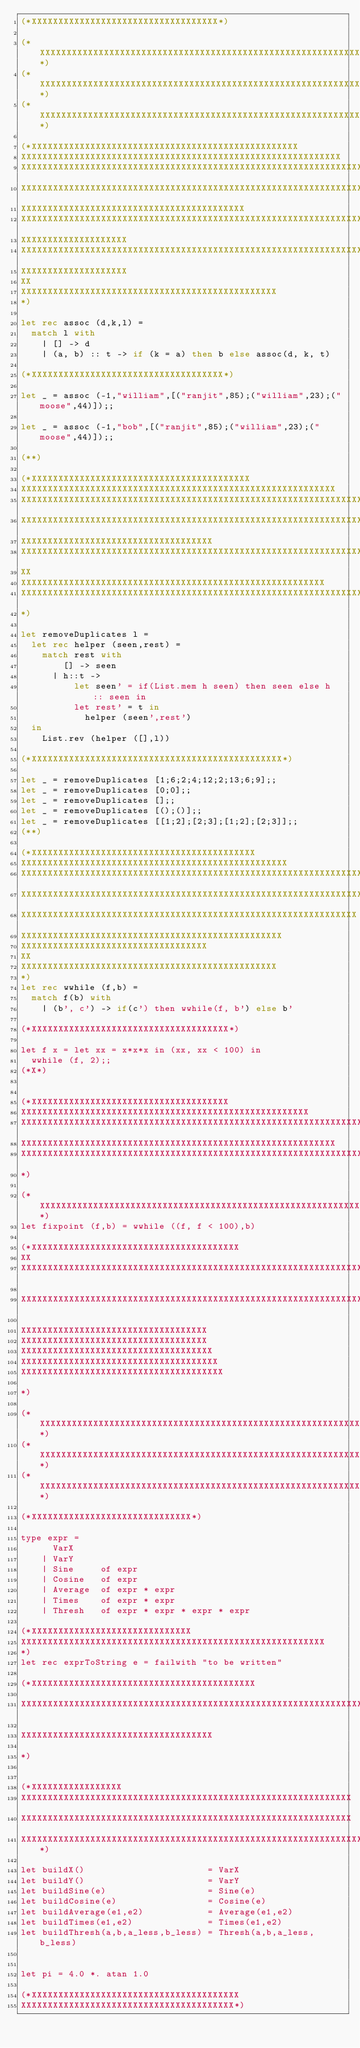Convert code to text. <code><loc_0><loc_0><loc_500><loc_500><_OCaml_>(*XXXXXXXXXXXXXXXXXXXXXXXXXXXXXXXXXXX*)

(*XXXXXXXXXXXXXXXXXXXXXXXXXXXXXXXXXXXXXXXXXXXXXXXXXXXXXXXXXXXXXXXXXXXXXXXXXXXXXXXXXXXXXX*)
(*XXXXXXXXXXXXXXXXXXXXXXXXXXXXXXXXXXXXXXXXXXXXXXXXXXXXXXXXXXXXXXXXXXXXXXXXXXXXXXXXXXXXXX*)
(*XXXXXXXXXXXXXXXXXXXXXXXXXXXXXXXXXXXXXXXXXXXXXXXXXXXXXXXXXXXXXXXXXXXXXXXXXXXXXXXXXXXXXX*)

(*XXXXXXXXXXXXXXXXXXXXXXXXXXXXXXXXXXXXXXXXXXXXXXXXXX
XXXXXXXXXXXXXXXXXXXXXXXXXXXXXXXXXXXXXXXXXXXXXXXXXXXXXXXXXXXX
XXXXXXXXXXXXXXXXXXXXXXXXXXXXXXXXXXXXXXXXXXXXXXXXXXXXXXXXXXXXXXXXXXXXXXXXXXXXXXXXXXX
XXXXXXXXXXXXXXXXXXXXXXXXXXXXXXXXXXXXXXXXXXXXXXXXXXXXXXXXXXXXXXXXXXXXXXXXXXXXXXXXXXXXX
XXXXXXXXXXXXXXXXXXXXXXXXXXXXXXXXXXXXXXXXXX
XXXXXXXXXXXXXXXXXXXXXXXXXXXXXXXXXXXXXXXXXXXXXXXXXXXXXXXXXXXXXXXXXXXXXXXXXX
XXXXXXXXXXXXXXXXXXXX
XXXXXXXXXXXXXXXXXXXXXXXXXXXXXXXXXXXXXXXXXXXXXXXXXXXXXXXXXXXXXXXXXXXXXX
XXXXXXXXXXXXXXXXXXXX
XX
XXXXXXXXXXXXXXXXXXXXXXXXXXXXXXXXXXXXXXXXXXXXXXXX
*)

let rec assoc (d,k,l) = 
  match l with
    | [] -> d
    | (a, b) :: t -> if (k = a) then b else assoc(d, k, t) 

(*XXXXXXXXXXXXXXXXXXXXXXXXXXXXXXXXXXXX*)

let _ = assoc (-1,"william",[("ranjit",85);("william",23);("moose",44)]);;    

let _ = assoc (-1,"bob",[("ranjit",85);("william",23);("moose",44)]);;

(**)

(*XXXXXXXXXXXXXXXXXXXXXXXXXXXXXXXXXXXXXXXXX
XXXXXXXXXXXXXXXXXXXXXXXXXXXXXXXXXXXXXXXXXXXXXXXXXXXXXXXXXXX
XXXXXXXXXXXXXXXXXXXXXXXXXXXXXXXXXXXXXXXXXXXXXXXXXXXXXXXXXXXXXXXXXXXXXXXXXXXXX
XXXXXXXXXXXXXXXXXXXXXXXXXXXXXXXXXXXXXXXXXXXXXXXXXXXXXXXXXXXXXXXXXXXX
XXXXXXXXXXXXXXXXXXXXXXXXXXXXXXXXXXXX
XXXXXXXXXXXXXXXXXXXXXXXXXXXXXXXXXXXXXXXXXXXXXXXXXXXXXXXXXXXXXXXXXXXXX
XX
XXXXXXXXXXXXXXXXXXXXXXXXXXXXXXXXXXXXXXXXXXXXXXXXXXXXXXXXX
XXXXXXXXXXXXXXXXXXXXXXXXXXXXXXXXXXXXXXXXXXXXXXXXXXXXXXXXXXXXXXXXXXXXXXXXXXXXXXXX
*)

let removeDuplicates l = 
  let rec helper (seen,rest) = 
    match rest with 
        [] -> seen
      | h::t -> 
          let seen' = if(List.mem h seen) then seen else h :: seen in
          let rest' = t in
            helper (seen',rest') 
  in 
    List.rev (helper ([],l))

(*XXXXXXXXXXXXXXXXXXXXXXXXXXXXXXXXXXXXXXXXXXXXXXX*)

let _ = removeDuplicates [1;6;2;4;12;2;13;6;9];;
let _ = removeDuplicates [0;0];;
let _ = removeDuplicates [];;
let _ = removeDuplicates [();()];;
let _ = removeDuplicates [[1;2];[2;3];[1;2];[2;3]];;
(**)

(*XXXXXXXXXXXXXXXXXXXXXXXXXXXXXXXXXXXXXXXXXX
XXXXXXXXXXXXXXXXXXXXXXXXXXXXXXXXXXXXXXXXXXXXXXXXXX
XXXXXXXXXXXXXXXXXXXXXXXXXXXXXXXXXXXXXXXXXXXXXXXXXXXXXXXXXXXXXXXXXXXXXXXXXXXXX
XXXXXXXXXXXXXXXXXXXXXXXXXXXXXXXXXXXXXXXXXXXXXXXXXXXXXXXXXXXXXXXXXXXXXXXXXXXXXXXXXXXX
XXXXXXXXXXXXXXXXXXXXXXXXXXXXXXXXXXXXXXXXXXXXXXXXXXXXXXXXXXXXXXX
XXXXXXXXXXXXXXXXXXXXXXXXXXXXXXXXXXXXXXXXXXXXXXXXX
XXXXXXXXXXXXXXXXXXXXXXXXXXXXXXXXXXX
XX
XXXXXXXXXXXXXXXXXXXXXXXXXXXXXXXXXXXXXXXXXXXXXXXX
*)
let rec wwhile (f,b) = 
  match f(b) with
    | (b', c') -> if(c') then wwhile(f, b') else b' 

(*XXXXXXXXXXXXXXXXXXXXXXXXXXXXXXXXXXXXX*)

let f x = let xx = x*x*x in (xx, xx < 100) in
  wwhile (f, 2);;
(*X*)


(*XXXXXXXXXXXXXXXXXXXXXXXXXXXXXXXXXXXXX
XXXXXXXXXXXXXXXXXXXXXXXXXXXXXXXXXXXXXXXXXXXXXXXXXXXXXX
XXXXXXXXXXXXXXXXXXXXXXXXXXXXXXXXXXXXXXXXXXXXXXXXXXXXXXXXXXXXXXXXXXXXXXXXXXXXXXXXX
XXXXXXXXXXXXXXXXXXXXXXXXXXXXXXXXXXXXXXXXXXXXXXXXXXXXXXXXXXX
XXXXXXXXXXXXXXXXXXXXXXXXXXXXXXXXXXXXXXXXXXXXXXXXXXXXXXXXXXXXXXXXXXXXXXXXXXXXXXXXXXXXXXXXXXXXXXXXXXXX
*)

(*XXXXXXXXXXXXXXXXXXXXXXXXXXXXXXXXXXXXXXXXXXXXXXXXXXXXXXXXXXXXXX*)
let fixpoint (f,b) = wwhile ((f, f < 100),b)

(*XXXXXXXXXXXXXXXXXXXXXXXXXXXXXXXXXXXXXXX
XX
XXXXXXXXXXXXXXXXXXXXXXXXXXXXXXXXXXXXXXXXXXXXXXXXXXXXXXXXXXXXXXXXXXXXXXXXXX

XXXXXXXXXXXXXXXXXXXXXXXXXXXXXXXXXXXXXXXXXXXXXXXXXXXXXXXXXXXXXXXXXXXXXXXXXXXXXXXXXXX

XXXXXXXXXXXXXXXXXXXXXXXXXXXXXXXXXXX
XXXXXXXXXXXXXXXXXXXXXXXXXXXXXXXXXXX
XXXXXXXXXXXXXXXXXXXXXXXXXXXXXXXXXXXX
XXXXXXXXXXXXXXXXXXXXXXXXXXXXXXXXXXXXX
XXXXXXXXXXXXXXXXXXXXXXXXXXXXXXXXXXXXXX

*)

(*XXXXXXXXXXXXXXXXXXXXXXXXXXXXXXXXXXXXXXXXXXXXXXXXXXXXXXXXXXXXXXXXXXXXXXXXXXXXXXXXXXXXXX*)
(*XXXXXXXXXXXXXXXXXXXXXXXXXXXXXXXXXXXXXXXXXXXXXXXXXXXXXXXXXXXXXXXXXXXXXXXXXXXXXXXXXXXXXX*)
(*XXXXXXXXXXXXXXXXXXXXXXXXXXXXXXXXXXXXXXXXXXXXXXXXXXXXXXXXXXXXXXXXXXXXXXXXXXXXXXXXXXXXXX*)

(*XXXXXXXXXXXXXXXXXXXXXXXXXXXXXX*) 

type expr = 
      VarX
    | VarY
    | Sine     of expr
    | Cosine   of expr
    | Average  of expr * expr
    | Times    of expr * expr
    | Thresh   of expr * expr * expr * expr	

(*XXXXXXXXXXXXXXXXXXXXXXXXXXXXXX
XXXXXXXXXXXXXXXXXXXXXXXXXXXXXXXXXXXXXXXXXXXXXXXXXXXXXXXXX
*)
let rec exprToString e = failwith "to be written"

(*XXXXXXXXXXXXXXXXXXXXXXXXXXXXXXXXXXXXXXXXXX

XXXXXXXXXXXXXXXXXXXXXXXXXXXXXXXXXXXXXXXXXXXXXXXXXXXXXXXXXXXXXXXXXXXXXXXXXXXXXXXXXXXXXXXXXXXX

XXXXXXXXXXXXXXXXXXXXXXXXXXXXXXXXXXXX

*)


(*XXXXXXXXXXXXXXXXX
XXXXXXXXXXXXXXXXXXXXXXXXXXXXXXXXXXXXXXXXXXXXXXXXXXXXXXXXXXXXXX
XXXXXXXXXXXXXXXXXXXXXXXXXXXXXXXXXXXXXXXXXXXXXXXXXXXXXXXXXXXXXX
XXXXXXXXXXXXXXXXXXXXXXXXXXXXXXXXXXXXXXXXXXXXXXXXXXXXXXXXXXXXXXXXXXX*)

let buildX()                       = VarX
let buildY()                       = VarY
let buildSine(e)                   = Sine(e)
let buildCosine(e)                 = Cosine(e)
let buildAverage(e1,e2)            = Average(e1,e2)
let buildTimes(e1,e2)              = Times(e1,e2)
let buildThresh(a,b,a_less,b_less) = Thresh(a,b,a_less,b_less)


let pi = 4.0 *. atan 1.0

(*XXXXXXXXXXXXXXXXXXXXXXXXXXXXXXXXXXXXXXX
XXXXXXXXXXXXXXXXXXXXXXXXXXXXXXXXXXXXXXXX*)
</code> 